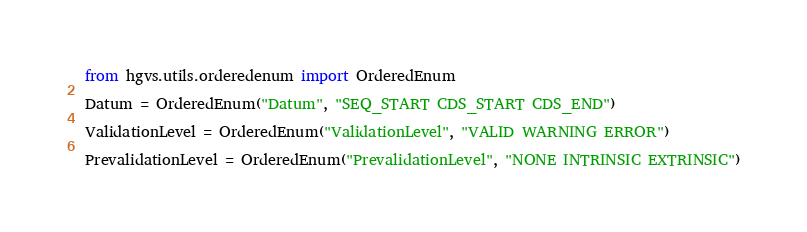Convert code to text. <code><loc_0><loc_0><loc_500><loc_500><_Python_>from hgvs.utils.orderedenum import OrderedEnum

Datum = OrderedEnum("Datum", "SEQ_START CDS_START CDS_END")

ValidationLevel = OrderedEnum("ValidationLevel", "VALID WARNING ERROR")

PrevalidationLevel = OrderedEnum("PrevalidationLevel", "NONE INTRINSIC EXTRINSIC")
</code> 